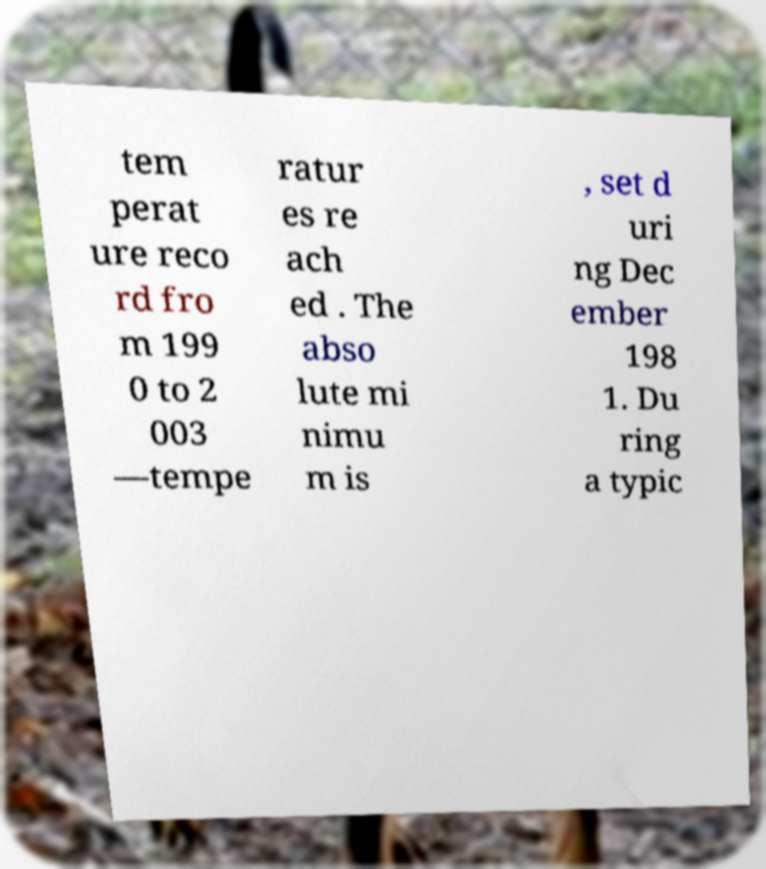There's text embedded in this image that I need extracted. Can you transcribe it verbatim? tem perat ure reco rd fro m 199 0 to 2 003 —tempe ratur es re ach ed . The abso lute mi nimu m is , set d uri ng Dec ember 198 1. Du ring a typic 